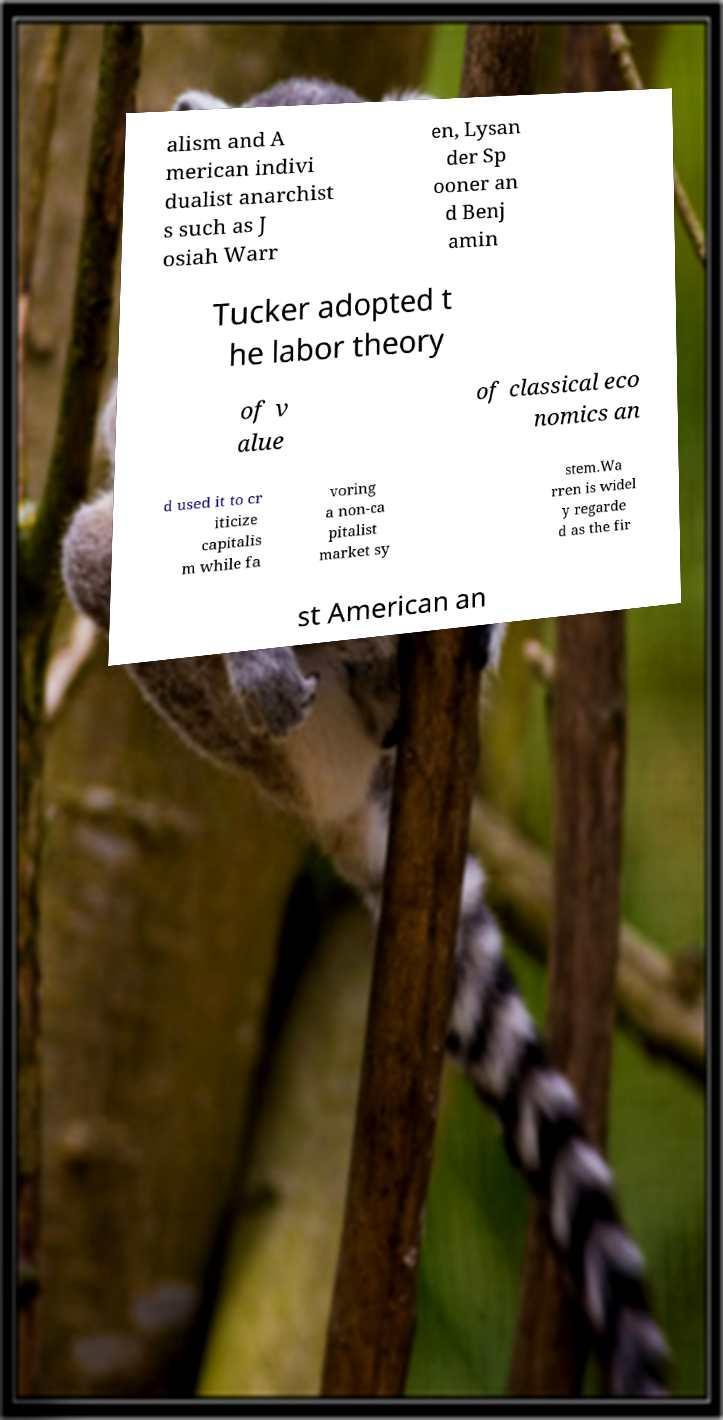Can you read and provide the text displayed in the image?This photo seems to have some interesting text. Can you extract and type it out for me? alism and A merican indivi dualist anarchist s such as J osiah Warr en, Lysan der Sp ooner an d Benj amin Tucker adopted t he labor theory of v alue of classical eco nomics an d used it to cr iticize capitalis m while fa voring a non-ca pitalist market sy stem.Wa rren is widel y regarde d as the fir st American an 